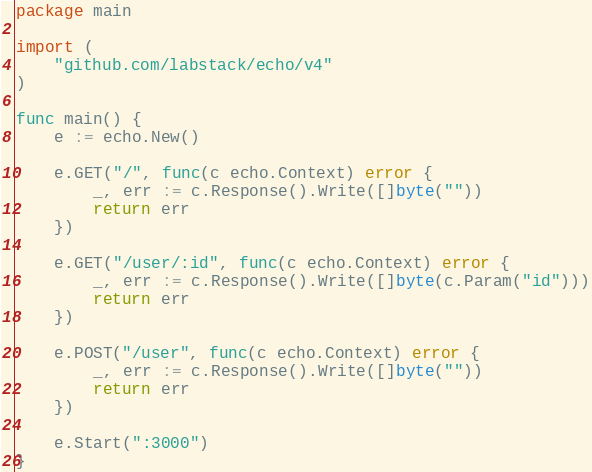Convert code to text. <code><loc_0><loc_0><loc_500><loc_500><_Go_>package main

import (
	"github.com/labstack/echo/v4"
)

func main() {
	e := echo.New()

	e.GET("/", func(c echo.Context) error {
		_, err := c.Response().Write([]byte(""))
		return err
	})

	e.GET("/user/:id", func(c echo.Context) error {
		_, err := c.Response().Write([]byte(c.Param("id")))
		return err
	})

	e.POST("/user", func(c echo.Context) error {
		_, err := c.Response().Write([]byte(""))
		return err
	})

	e.Start(":3000")
}
</code> 